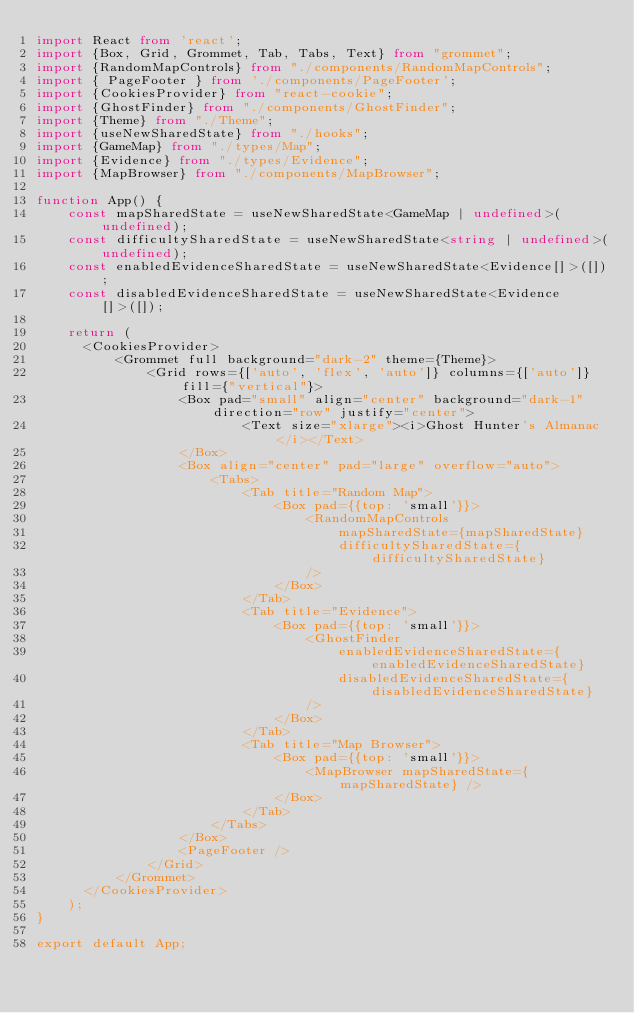Convert code to text. <code><loc_0><loc_0><loc_500><loc_500><_TypeScript_>import React from 'react';
import {Box, Grid, Grommet, Tab, Tabs, Text} from "grommet";
import {RandomMapControls} from "./components/RandomMapControls";
import { PageFooter } from './components/PageFooter';
import {CookiesProvider} from "react-cookie";
import {GhostFinder} from "./components/GhostFinder";
import {Theme} from "./Theme";
import {useNewSharedState} from "./hooks";
import {GameMap} from "./types/Map";
import {Evidence} from "./types/Evidence";
import {MapBrowser} from "./components/MapBrowser";

function App() {
    const mapSharedState = useNewSharedState<GameMap | undefined>(undefined);
    const difficultySharedState = useNewSharedState<string | undefined>(undefined);
    const enabledEvidenceSharedState = useNewSharedState<Evidence[]>([]);
    const disabledEvidenceSharedState = useNewSharedState<Evidence[]>([]);

    return (
      <CookiesProvider>
          <Grommet full background="dark-2" theme={Theme}>
              <Grid rows={['auto', 'flex', 'auto']} columns={['auto']} fill={"vertical"}>
                  <Box pad="small" align="center" background="dark-1" direction="row" justify="center">
                          <Text size="xlarge"><i>Ghost Hunter's Almanac</i></Text>
                  </Box>
                  <Box align="center" pad="large" overflow="auto">
                      <Tabs>
                          <Tab title="Random Map">
                              <Box pad={{top: 'small'}}>
                                  <RandomMapControls
                                      mapSharedState={mapSharedState}
                                      difficultySharedState={difficultySharedState}
                                  />
                              </Box>
                          </Tab>
                          <Tab title="Evidence">
                              <Box pad={{top: 'small'}}>
                                  <GhostFinder
                                      enabledEvidenceSharedState={enabledEvidenceSharedState}
                                      disabledEvidenceSharedState={disabledEvidenceSharedState}
                                  />
                              </Box>
                          </Tab>
                          <Tab title="Map Browser">
                              <Box pad={{top: 'small'}}>
                                  <MapBrowser mapSharedState={mapSharedState} />
                              </Box>
                          </Tab>
                      </Tabs>
                  </Box>
                  <PageFooter />
              </Grid>
          </Grommet>
      </CookiesProvider>
    );
}

export default App;
</code> 